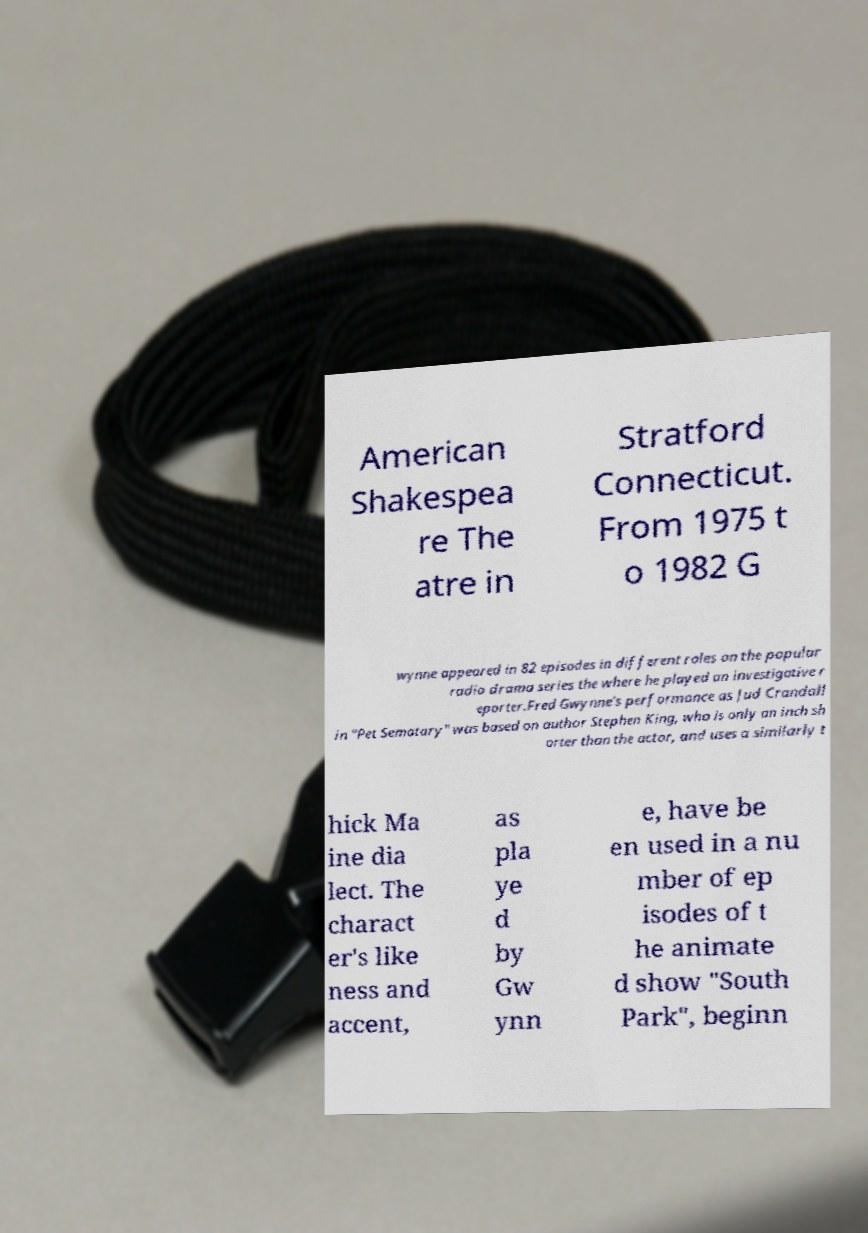Could you extract and type out the text from this image? American Shakespea re The atre in Stratford Connecticut. From 1975 t o 1982 G wynne appeared in 82 episodes in different roles on the popular radio drama series the where he played an investigative r eporter.Fred Gwynne's performance as Jud Crandall in "Pet Sematary" was based on author Stephen King, who is only an inch sh orter than the actor, and uses a similarly t hick Ma ine dia lect. The charact er's like ness and accent, as pla ye d by Gw ynn e, have be en used in a nu mber of ep isodes of t he animate d show "South Park", beginn 